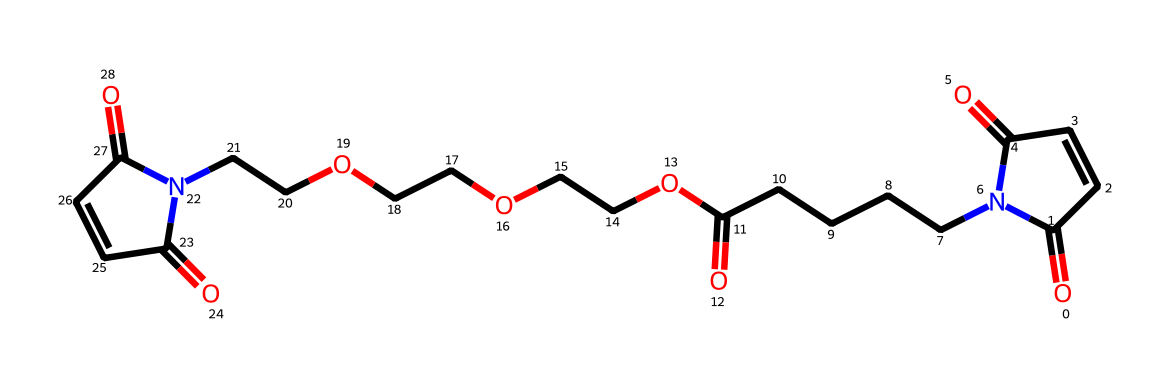What is the total number of carbon atoms in this structure? Counting the carbon atoms in the provided SMILES notation, we find that there are 14 carbon atoms. Each 'C' represents one carbon atom, and we sum each instance present.
Answer: 14 How many nitrogen atoms are present in this molecule? In the SMILES representation, we can find two occurrences of the symbol 'N', which indicates that there are two nitrogen atoms in the structure.
Answer: 2 What functional groups are indicated by the structure? By analyzing the SMILES notation, we can identify multiple carbonyl groups (C=O) and amine groups (N), specifically the imide functional group due to the arrangement of carbonyls adjacent to nitrogen.
Answer: carbonyl and amine What type of compound is represented by this structure? The structure contains imide linkages as indicated by the cyclic arrangement of carbonyls with nitrogen, thus classifying it as an imide compound.
Answer: imide Does this compound contain any ether linkages? In the SMILES notation, we observe 'OCCOCC' which signifies the presence of ether linkages between carbon chains and oxygen.
Answer: yes How is the structure likely to influence flexibility in materials? The presence of imide linkages and flexible carbon chains contributes to lower rigidity and enhances the ability of the material to bend, aiding in durability and flexibility for e-reader screens.
Answer: flexible 